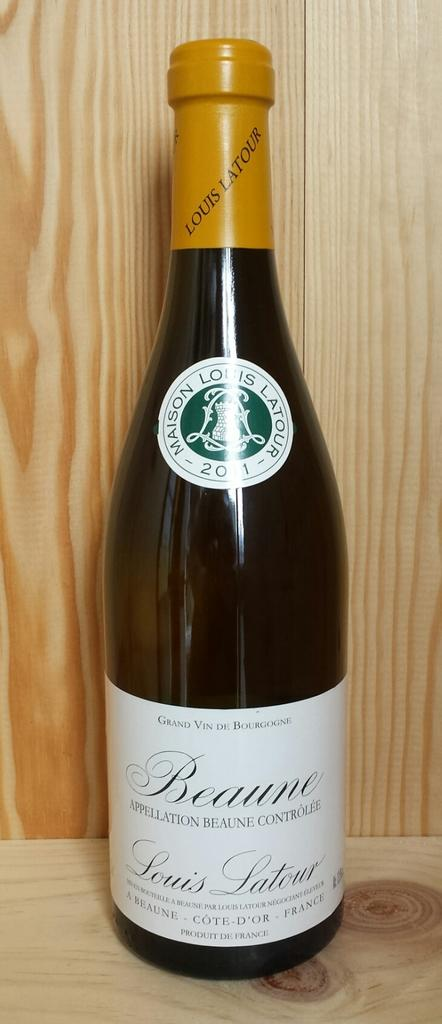<image>
Give a short and clear explanation of the subsequent image. An unopened bottle of Maison Louis Latour wine. 